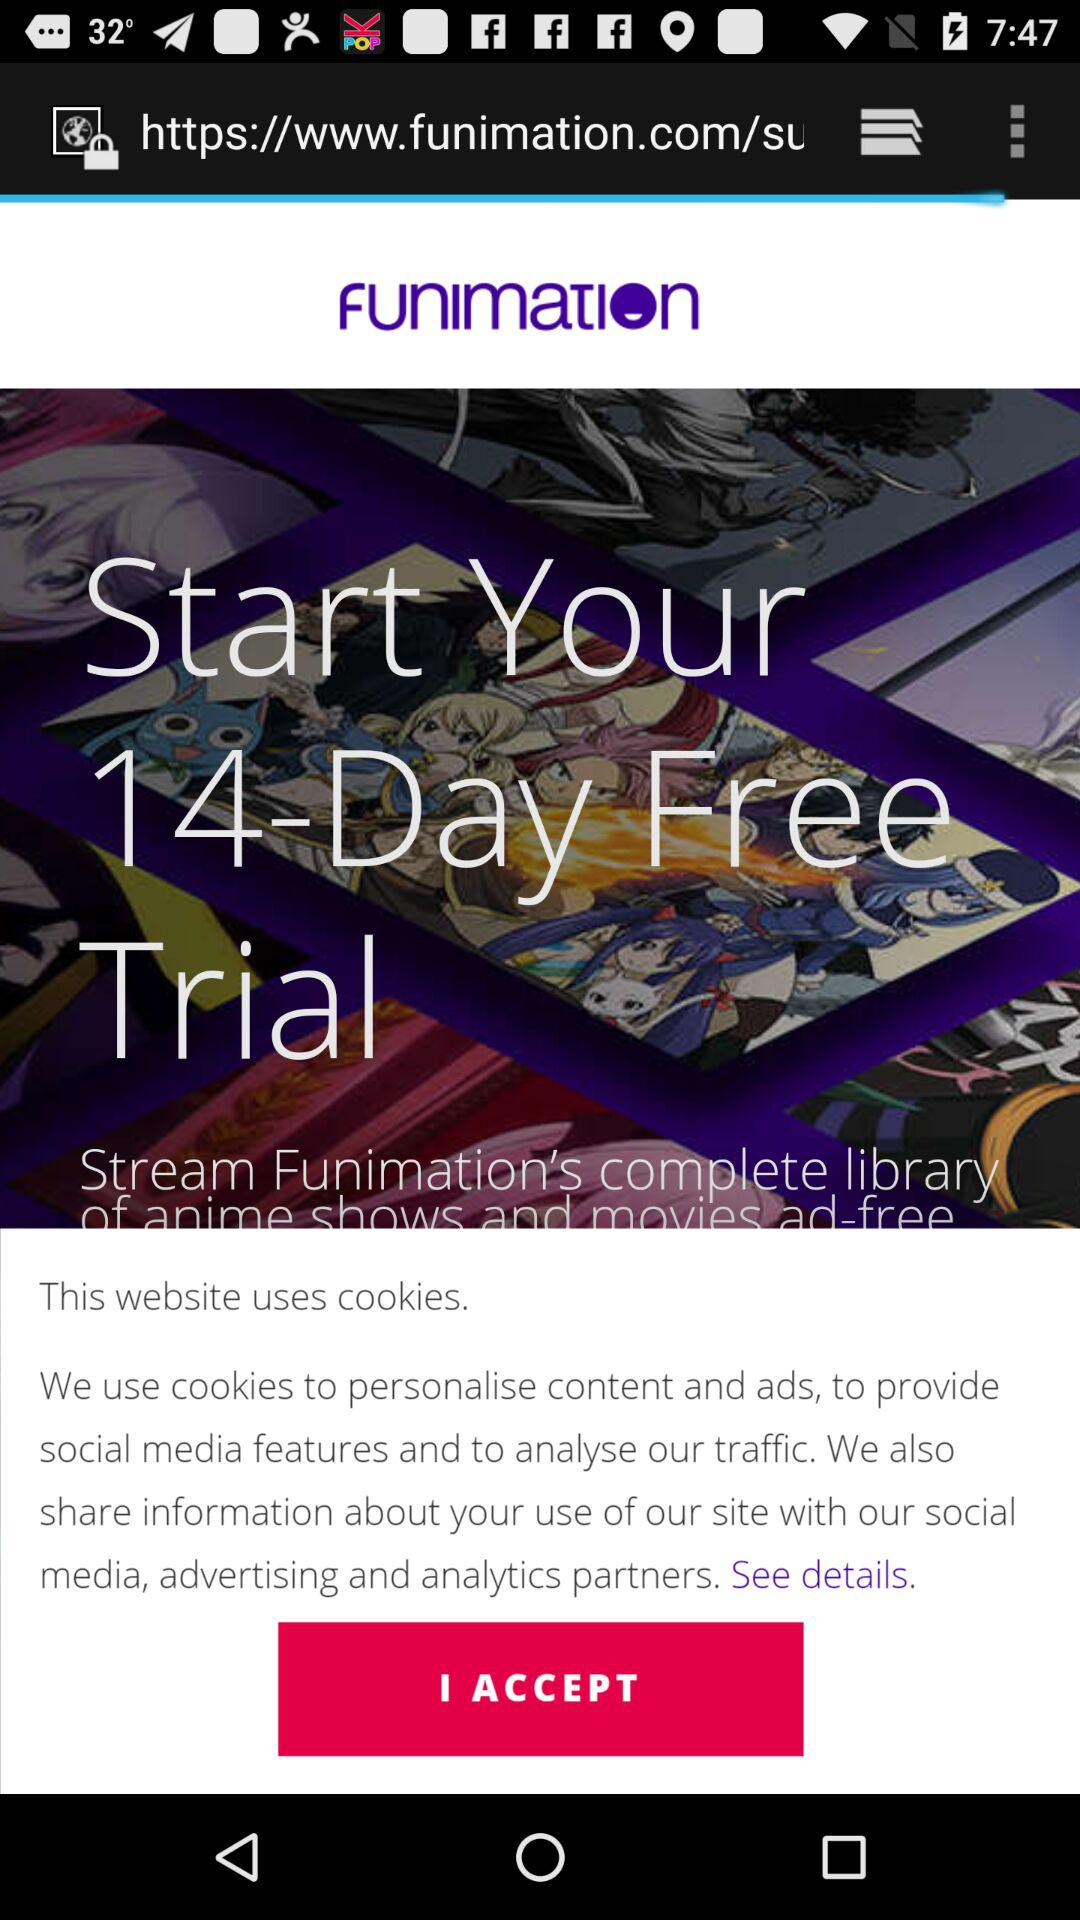What is the name of the application? The name of the application is "Funimation". 